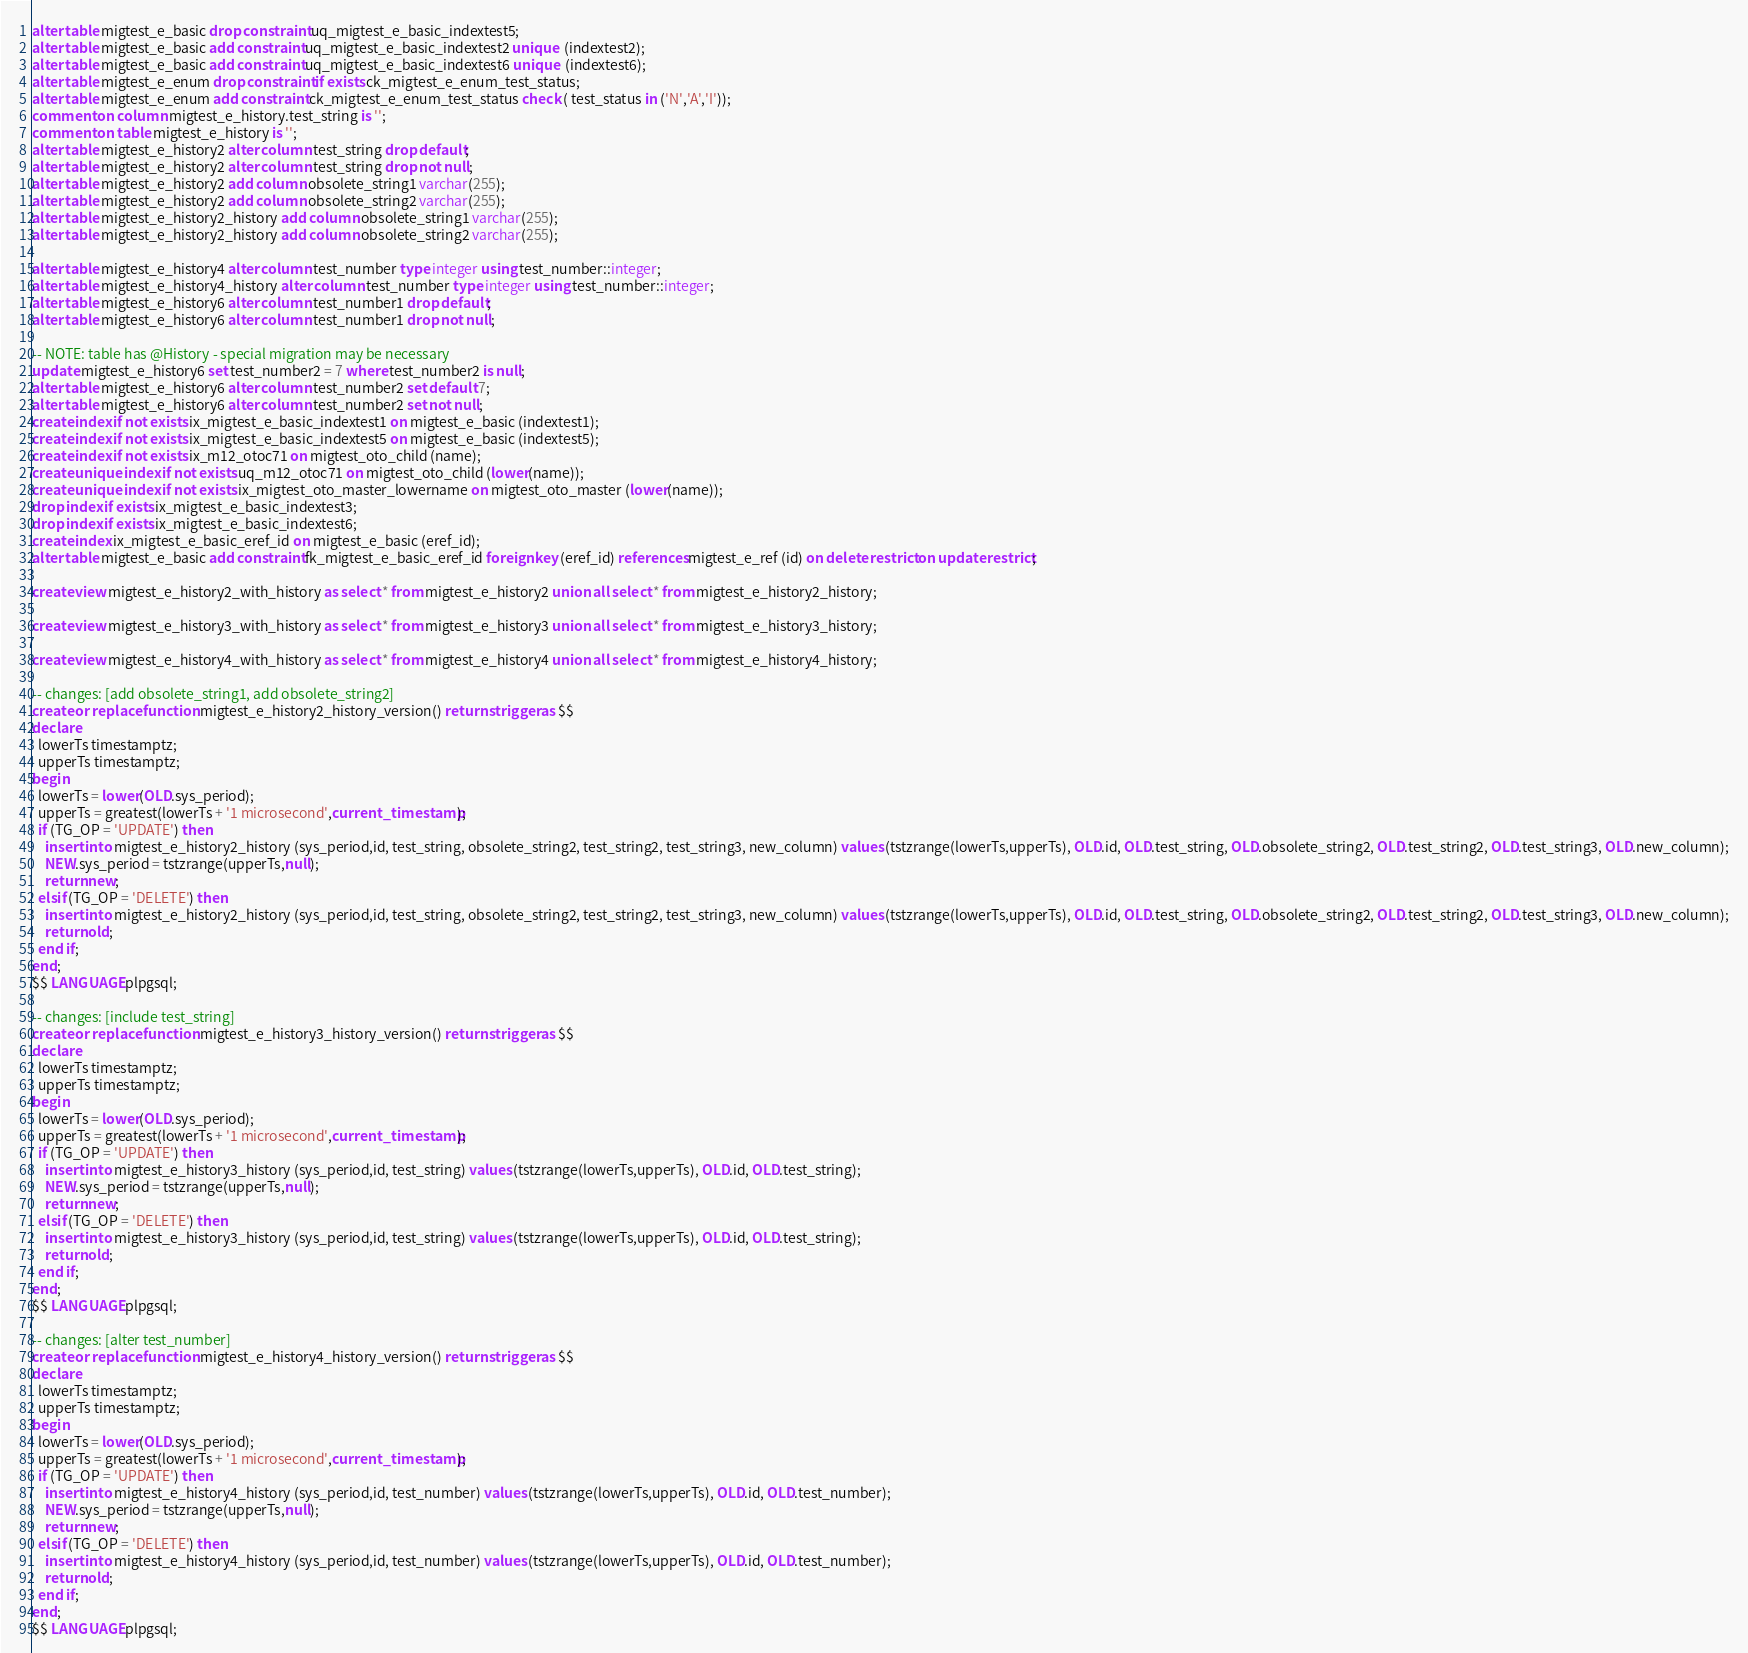Convert code to text. <code><loc_0><loc_0><loc_500><loc_500><_SQL_>alter table migtest_e_basic drop constraint uq_migtest_e_basic_indextest5;
alter table migtest_e_basic add constraint uq_migtest_e_basic_indextest2 unique  (indextest2);
alter table migtest_e_basic add constraint uq_migtest_e_basic_indextest6 unique  (indextest6);
alter table migtest_e_enum drop constraint if exists ck_migtest_e_enum_test_status;
alter table migtest_e_enum add constraint ck_migtest_e_enum_test_status check ( test_status in ('N','A','I'));
comment on column migtest_e_history.test_string is '';
comment on table migtest_e_history is '';
alter table migtest_e_history2 alter column test_string drop default;
alter table migtest_e_history2 alter column test_string drop not null;
alter table migtest_e_history2 add column obsolete_string1 varchar(255);
alter table migtest_e_history2 add column obsolete_string2 varchar(255);
alter table migtest_e_history2_history add column obsolete_string1 varchar(255);
alter table migtest_e_history2_history add column obsolete_string2 varchar(255);

alter table migtest_e_history4 alter column test_number type integer using test_number::integer;
alter table migtest_e_history4_history alter column test_number type integer using test_number::integer;
alter table migtest_e_history6 alter column test_number1 drop default;
alter table migtest_e_history6 alter column test_number1 drop not null;

-- NOTE: table has @History - special migration may be necessary
update migtest_e_history6 set test_number2 = 7 where test_number2 is null;
alter table migtest_e_history6 alter column test_number2 set default 7;
alter table migtest_e_history6 alter column test_number2 set not null;
create index if not exists ix_migtest_e_basic_indextest1 on migtest_e_basic (indextest1);
create index if not exists ix_migtest_e_basic_indextest5 on migtest_e_basic (indextest5);
create index if not exists ix_m12_otoc71 on migtest_oto_child (name);
create unique index if not exists uq_m12_otoc71 on migtest_oto_child (lower(name));
create unique index if not exists ix_migtest_oto_master_lowername on migtest_oto_master (lower(name));
drop index if exists ix_migtest_e_basic_indextest3;
drop index if exists ix_migtest_e_basic_indextest6;
create index ix_migtest_e_basic_eref_id on migtest_e_basic (eref_id);
alter table migtest_e_basic add constraint fk_migtest_e_basic_eref_id foreign key (eref_id) references migtest_e_ref (id) on delete restrict on update restrict;

create view migtest_e_history2_with_history as select * from migtest_e_history2 union all select * from migtest_e_history2_history;

create view migtest_e_history3_with_history as select * from migtest_e_history3 union all select * from migtest_e_history3_history;

create view migtest_e_history4_with_history as select * from migtest_e_history4 union all select * from migtest_e_history4_history;

-- changes: [add obsolete_string1, add obsolete_string2]
create or replace function migtest_e_history2_history_version() returns trigger as $$
declare
  lowerTs timestamptz;
  upperTs timestamptz;
begin
  lowerTs = lower(OLD.sys_period);
  upperTs = greatest(lowerTs + '1 microsecond',current_timestamp);
  if (TG_OP = 'UPDATE') then
    insert into migtest_e_history2_history (sys_period,id, test_string, obsolete_string2, test_string2, test_string3, new_column) values (tstzrange(lowerTs,upperTs), OLD.id, OLD.test_string, OLD.obsolete_string2, OLD.test_string2, OLD.test_string3, OLD.new_column);
    NEW.sys_period = tstzrange(upperTs,null);
    return new;
  elsif (TG_OP = 'DELETE') then
    insert into migtest_e_history2_history (sys_period,id, test_string, obsolete_string2, test_string2, test_string3, new_column) values (tstzrange(lowerTs,upperTs), OLD.id, OLD.test_string, OLD.obsolete_string2, OLD.test_string2, OLD.test_string3, OLD.new_column);
    return old;
  end if;
end;
$$ LANGUAGE plpgsql;

-- changes: [include test_string]
create or replace function migtest_e_history3_history_version() returns trigger as $$
declare
  lowerTs timestamptz;
  upperTs timestamptz;
begin
  lowerTs = lower(OLD.sys_period);
  upperTs = greatest(lowerTs + '1 microsecond',current_timestamp);
  if (TG_OP = 'UPDATE') then
    insert into migtest_e_history3_history (sys_period,id, test_string) values (tstzrange(lowerTs,upperTs), OLD.id, OLD.test_string);
    NEW.sys_period = tstzrange(upperTs,null);
    return new;
  elsif (TG_OP = 'DELETE') then
    insert into migtest_e_history3_history (sys_period,id, test_string) values (tstzrange(lowerTs,upperTs), OLD.id, OLD.test_string);
    return old;
  end if;
end;
$$ LANGUAGE plpgsql;

-- changes: [alter test_number]
create or replace function migtest_e_history4_history_version() returns trigger as $$
declare
  lowerTs timestamptz;
  upperTs timestamptz;
begin
  lowerTs = lower(OLD.sys_period);
  upperTs = greatest(lowerTs + '1 microsecond',current_timestamp);
  if (TG_OP = 'UPDATE') then
    insert into migtest_e_history4_history (sys_period,id, test_number) values (tstzrange(lowerTs,upperTs), OLD.id, OLD.test_number);
    NEW.sys_period = tstzrange(upperTs,null);
    return new;
  elsif (TG_OP = 'DELETE') then
    insert into migtest_e_history4_history (sys_period,id, test_number) values (tstzrange(lowerTs,upperTs), OLD.id, OLD.test_number);
    return old;
  end if;
end;
$$ LANGUAGE plpgsql;

</code> 